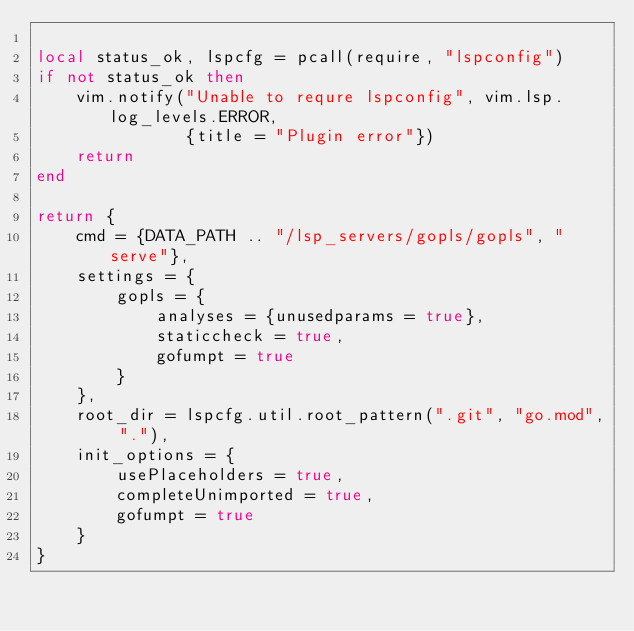<code> <loc_0><loc_0><loc_500><loc_500><_Lua_>
local status_ok, lspcfg = pcall(require, "lspconfig")
if not status_ok then
    vim.notify("Unable to requre lspconfig", vim.lsp.log_levels.ERROR,
               {title = "Plugin error"})
    return
end

return {
    cmd = {DATA_PATH .. "/lsp_servers/gopls/gopls", "serve"},
    settings = {
        gopls = {
            analyses = {unusedparams = true},
            staticcheck = true,
            gofumpt = true
        }
    },
    root_dir = lspcfg.util.root_pattern(".git", "go.mod", "."),
    init_options = {
        usePlaceholders = true,
        completeUnimported = true,
        gofumpt = true
    }
}
</code> 